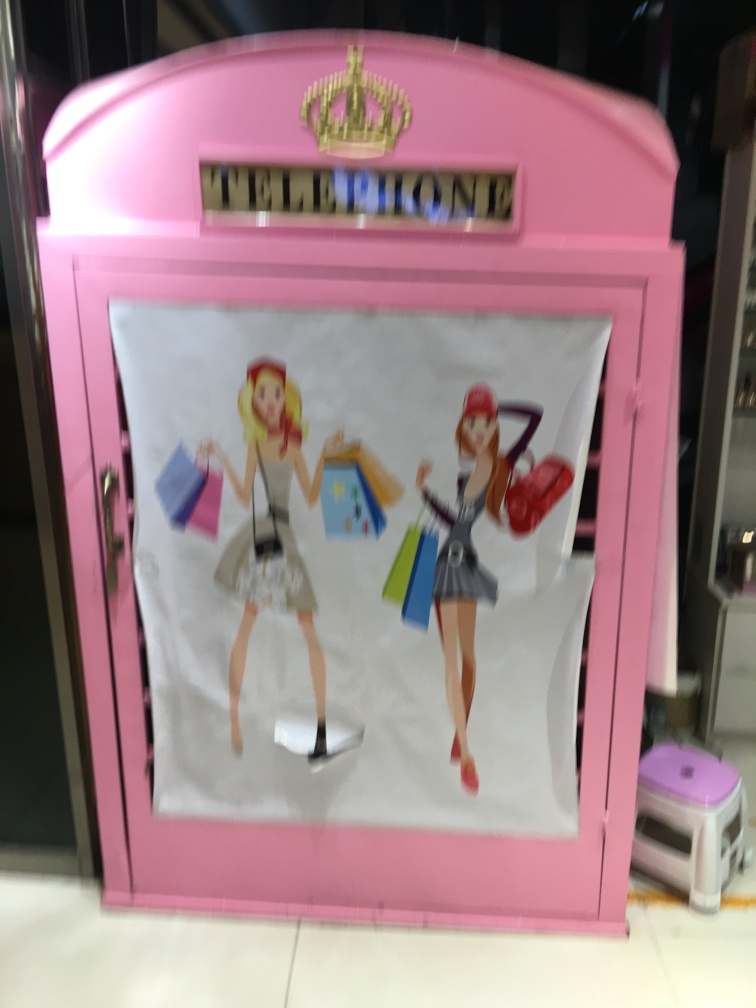What colors stand out to you in this image? The pink hue of the telephone booth is the most striking color, which contrasts with the neutral color of the floor and the surrounding environment. This choice of color may be intended to attract attention and evoke a playful or whimsical feeling. 